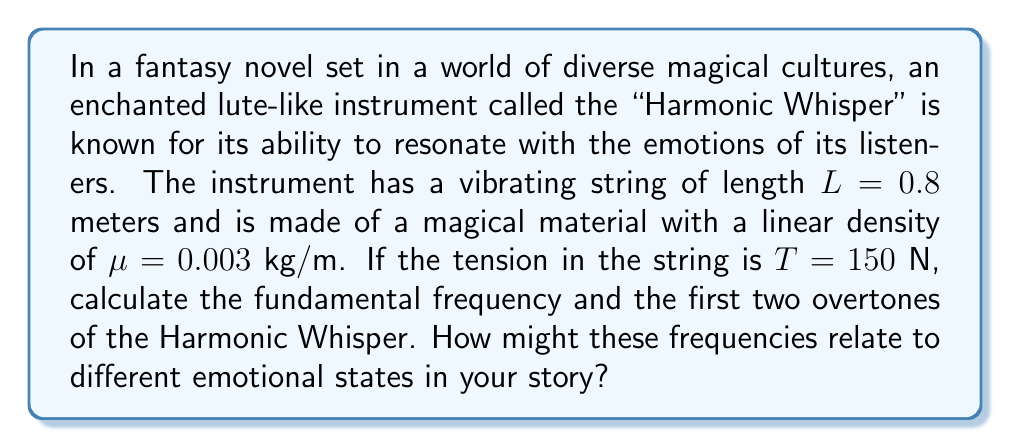Could you help me with this problem? To solve this problem, we'll use the wave equation for a vibrating string:

1) The formula for the frequency of a vibrating string is:

   $$f_n = \frac{n}{2L}\sqrt{\frac{T}{\mu}}$$

   where $n$ is the harmonic number, $L$ is the length of the string, $T$ is the tension, and $\mu$ is the linear density.

2) For the fundamental frequency, $n = 1$:

   $$f_1 = \frac{1}{2(0.8)}\sqrt{\frac{150}{0.003}} = 111.8 \text{ Hz}$$

3) For the first overtone (second harmonic), $n = 2$:

   $$f_2 = \frac{2}{2(0.8)}\sqrt{\frac{150}{0.003}} = 223.6 \text{ Hz}$$

4) For the second overtone (third harmonic), $n = 3$:

   $$f_3 = \frac{3}{2(0.8)}\sqrt{\frac{150}{0.003}} = 335.4 \text{ Hz}$$

These frequencies could be associated with different emotions in the story:
- The fundamental frequency (111.8 Hz) might represent a calm or neutral emotional state.
- The first overtone (223.6 Hz) could be linked to more energetic or joyful emotions.
- The second overtone (335.4 Hz) might correspond to intense or passionate feelings.
Answer: Fundamental: 111.8 Hz, First overtone: 223.6 Hz, Second overtone: 335.4 Hz 